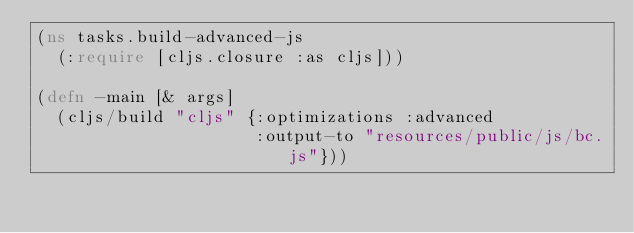Convert code to text. <code><loc_0><loc_0><loc_500><loc_500><_Clojure_>(ns tasks.build-advanced-js
  (:require [cljs.closure :as cljs]))

(defn -main [& args]
  (cljs/build "cljs" {:optimizations :advanced
                      :output-to "resources/public/js/bc.js"}))
</code> 